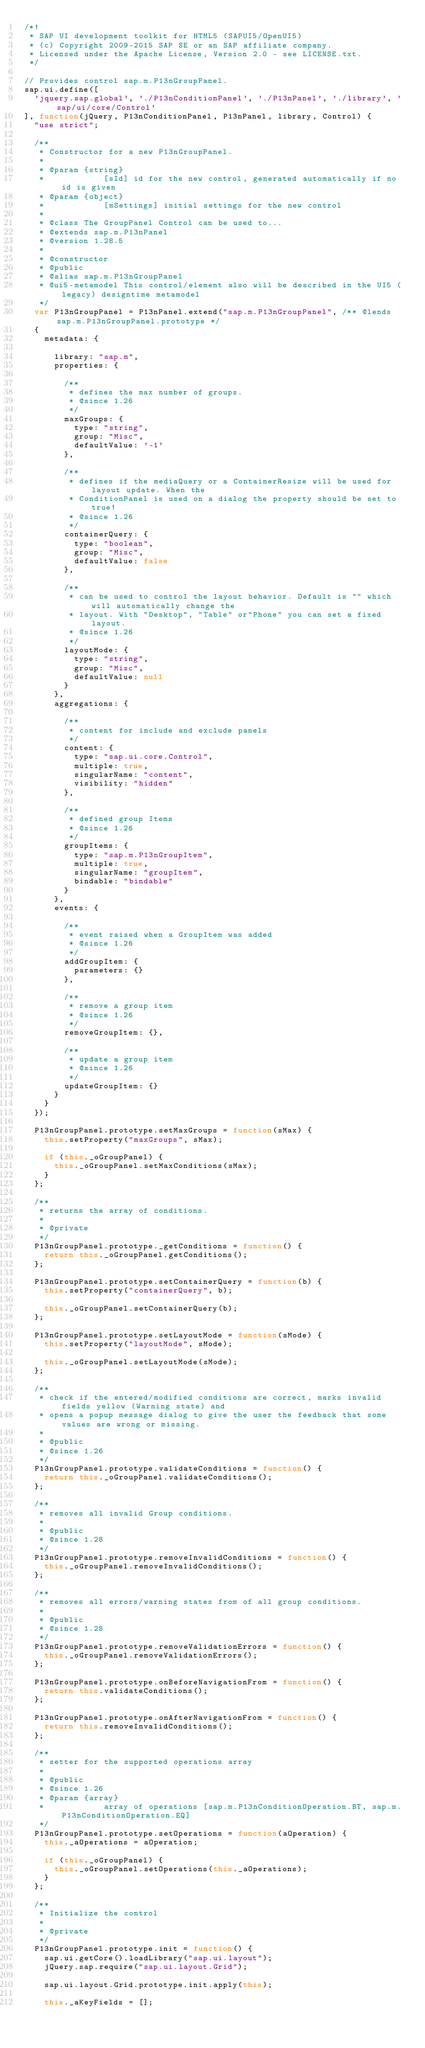<code> <loc_0><loc_0><loc_500><loc_500><_JavaScript_>/*!
 * SAP UI development toolkit for HTML5 (SAPUI5/OpenUI5)
 * (c) Copyright 2009-2015 SAP SE or an SAP affiliate company.
 * Licensed under the Apache License, Version 2.0 - see LICENSE.txt.
 */

// Provides control sap.m.P13nGroupPanel.
sap.ui.define([
	'jquery.sap.global', './P13nConditionPanel', './P13nPanel', './library', 'sap/ui/core/Control'
], function(jQuery, P13nConditionPanel, P13nPanel, library, Control) {
	"use strict";

	/**
	 * Constructor for a new P13nGroupPanel.
	 * 
	 * @param {string}
	 *            [sId] id for the new control, generated automatically if no id is given
	 * @param {object}
	 *            [mSettings] initial settings for the new control
	 * 
	 * @class The GroupPanel Control can be used to...
	 * @extends sap.m.P13nPanel
	 * @version 1.28.5
	 * 
	 * @constructor
	 * @public
	 * @alias sap.m.P13nGroupPanel
	 * @ui5-metamodel This control/element also will be described in the UI5 (legacy) designtime metamodel
	 */
	var P13nGroupPanel = P13nPanel.extend("sap.m.P13nGroupPanel", /** @lends sap.m.P13nGroupPanel.prototype */
	{
		metadata: {

			library: "sap.m",
			properties: {

				/**
				 * defines the max number of groups.
				 * @since 1.26
				 */
				maxGroups: {
					type: "string",
					group: "Misc",
					defaultValue: '-1'
				},

				/**
				 * defines if the mediaQuery or a ContainerResize will be used for layout update. When the
				 * ConditionPanel is used on a dialog the property should be set to true!
				 * @since 1.26
				 */
				containerQuery: {
					type: "boolean",
					group: "Misc",
					defaultValue: false
				},

				/**
				 * can be used to control the layout behavior. Default is "" which will automatically change the
				 * layout. With "Desktop", "Table" or"Phone" you can set a fixed layout.
				 * @since 1.26
				 */
				layoutMode: {
					type: "string",
					group: "Misc",
					defaultValue: null
				}
			},
			aggregations: {

				/**
				 * content for include and exclude panels
				 */
				content: {
					type: "sap.ui.core.Control",
					multiple: true,
					singularName: "content",
					visibility: "hidden"
				},

				/**
				 * defined group Items
				 * @since 1.26
				 */
				groupItems: {
					type: "sap.m.P13nGroupItem",
					multiple: true,
					singularName: "groupItem",
					bindable: "bindable"
				}
			},
			events: {

				/**
				 * event raised when a GroupItem was added
				 * @since 1.26
				 */
				addGroupItem: {
					parameters: {}
				},

				/**
				 * remove a group item
				 * @since 1.26
				 */
				removeGroupItem: {},

				/**								 
				 * update a group item
				 * @since 1.26
				 */
				updateGroupItem: {}
			}
		}
	});

	P13nGroupPanel.prototype.setMaxGroups = function(sMax) {
		this.setProperty("maxGroups", sMax);

		if (this._oGroupPanel) {
			this._oGroupPanel.setMaxConditions(sMax);
		}
	};

	/**
	 * returns the array of conditions.
	 * 
	 * @private
	 */
	P13nGroupPanel.prototype._getConditions = function() {
		return this._oGroupPanel.getConditions();
	};

	P13nGroupPanel.prototype.setContainerQuery = function(b) {
		this.setProperty("containerQuery", b);

		this._oGroupPanel.setContainerQuery(b);
	};

	P13nGroupPanel.prototype.setLayoutMode = function(sMode) {
		this.setProperty("layoutMode", sMode);

		this._oGroupPanel.setLayoutMode(sMode);
	};

	/**
	 * check if the entered/modified conditions are correct, marks invalid fields yellow (Warning state) and
	 * opens a popup message dialog to give the user the feedback that some values are wrong or missing.
	 * 
	 * @public
	 * @since 1.26
	 */
	P13nGroupPanel.prototype.validateConditions = function() {
		return this._oGroupPanel.validateConditions();
	};

	/**
	 * removes all invalid Group conditions.					 
	 *  
	 * @public
	 * @since 1.28
	 */
	P13nGroupPanel.prototype.removeInvalidConditions = function() {
		this._oGroupPanel.removeInvalidConditions();
	};

	/**
	 * removes all errors/warning states from of all group conditions.
	 * 
	 * @public
	 * @since 1.28
	 */
	P13nGroupPanel.prototype.removeValidationErrors = function() {
		this._oGroupPanel.removeValidationErrors();
	};

	P13nGroupPanel.prototype.onBeforeNavigationFrom = function() {
		return this.validateConditions();
	};

	P13nGroupPanel.prototype.onAfterNavigationFrom = function() {
		return this.removeInvalidConditions();
	};

	/**
	 * setter for the supported operations array
	 * 
	 * @public
	 * @since 1.26
	 * @param {array}
	 *            array of operations [sap.m.P13nConditionOperation.BT, sap.m.P13nConditionOperation.EQ]
	 */
	P13nGroupPanel.prototype.setOperations = function(aOperation) {
		this._aOperations = aOperation;

		if (this._oGroupPanel) {
			this._oGroupPanel.setOperations(this._aOperations);
		}
	};

	/**
	 * Initialize the control
	 * 
	 * @private
	 */
	P13nGroupPanel.prototype.init = function() {
		sap.ui.getCore().loadLibrary("sap.ui.layout");
		jQuery.sap.require("sap.ui.layout.Grid");

		sap.ui.layout.Grid.prototype.init.apply(this);

		this._aKeyFields = [];</code> 